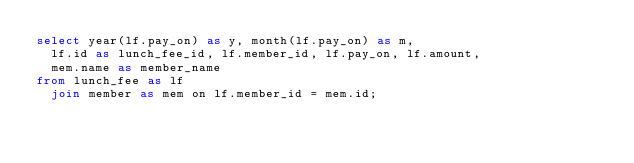Convert code to text. <code><loc_0><loc_0><loc_500><loc_500><_SQL_>select year(lf.pay_on) as y, month(lf.pay_on) as m,
  lf.id as lunch_fee_id, lf.member_id, lf.pay_on, lf.amount,
  mem.name as member_name
from lunch_fee as lf
  join member as mem on lf.member_id = mem.id;</code> 